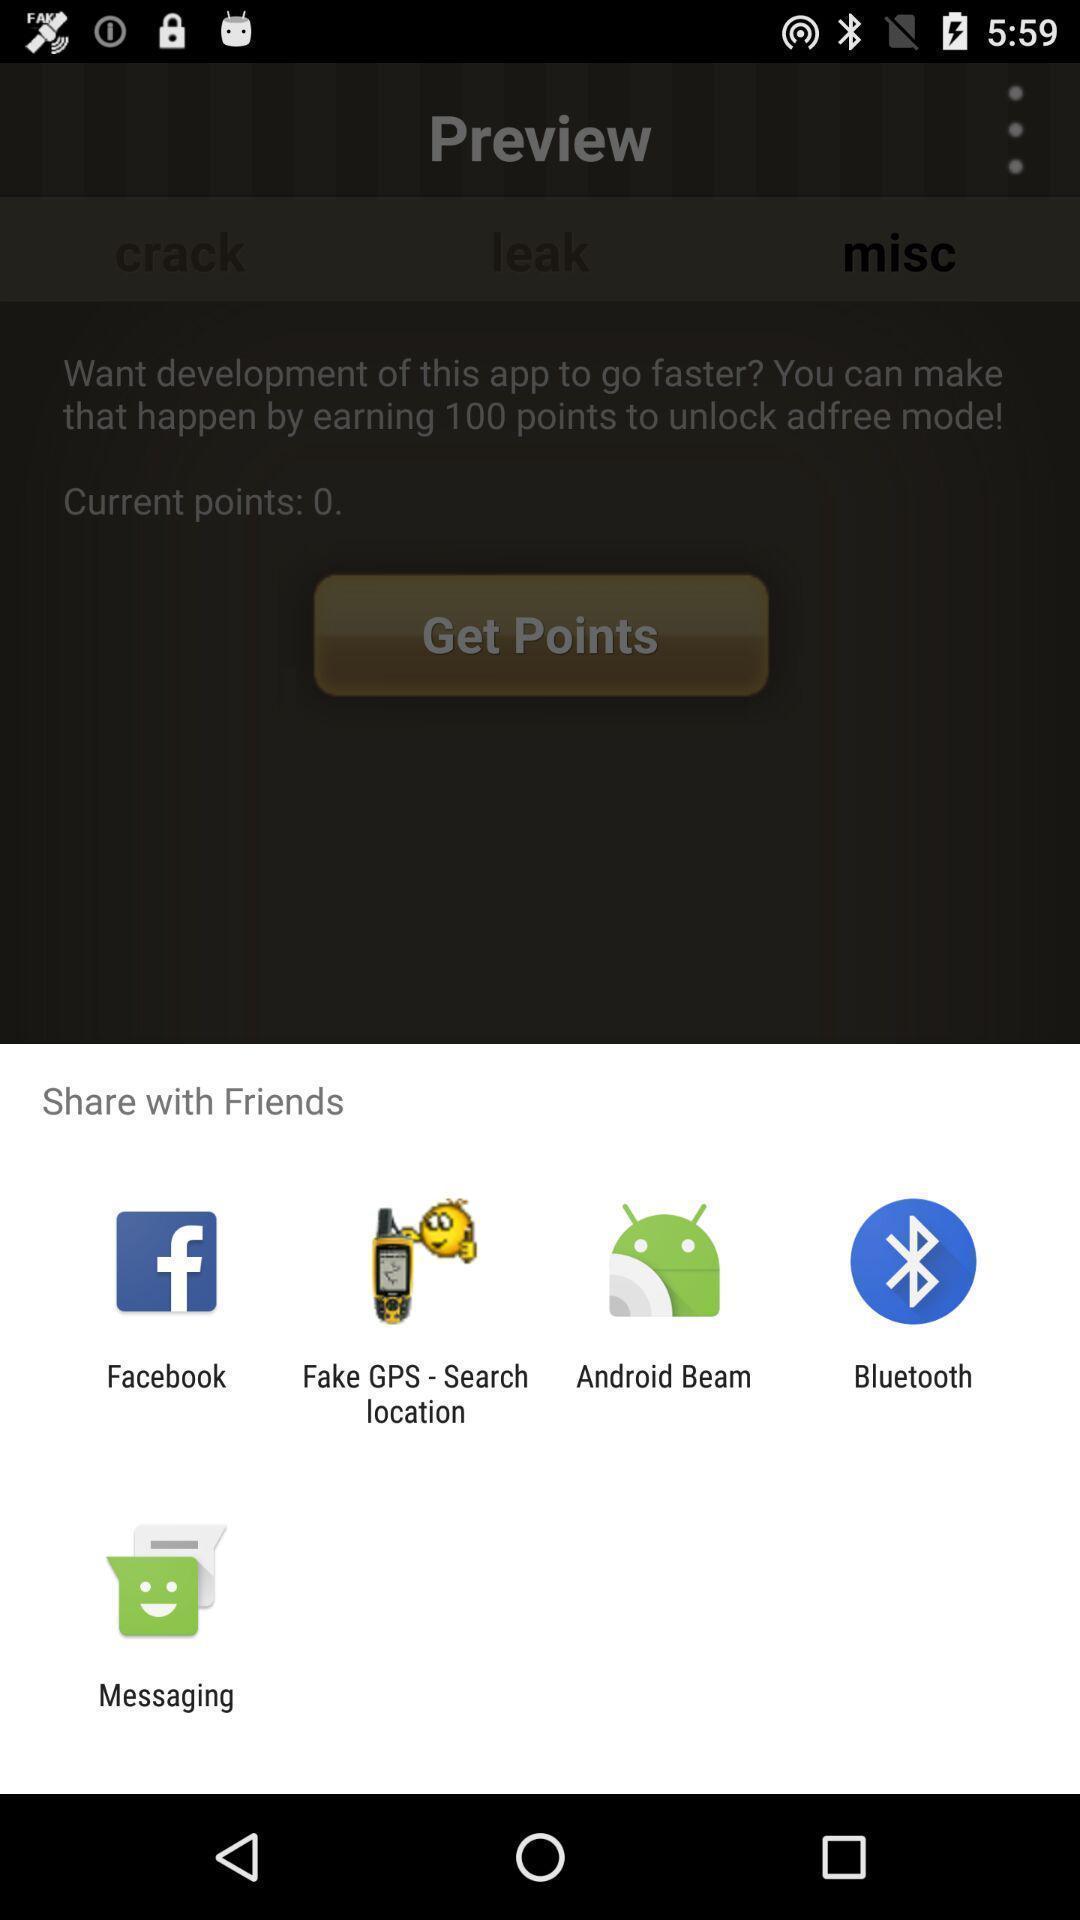Describe this image in words. Pop-up displaying different applications to share. 